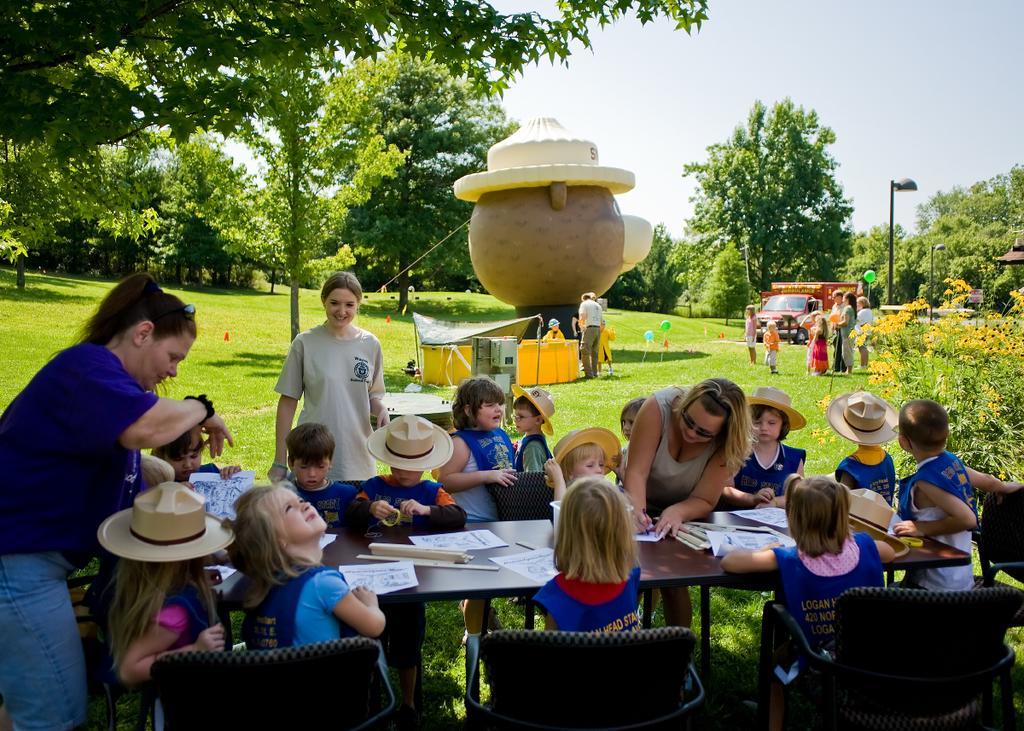In one or two sentences, can you explain what this image depicts? This image is taken in outdoors. At the top of the image there is a sky. At the background there are many trees and plants. In this image there are many people few are sitting on chairs and few are standing. In the middle of the image there is a toy balloon. In the right side of the image there is a street light with pole. 